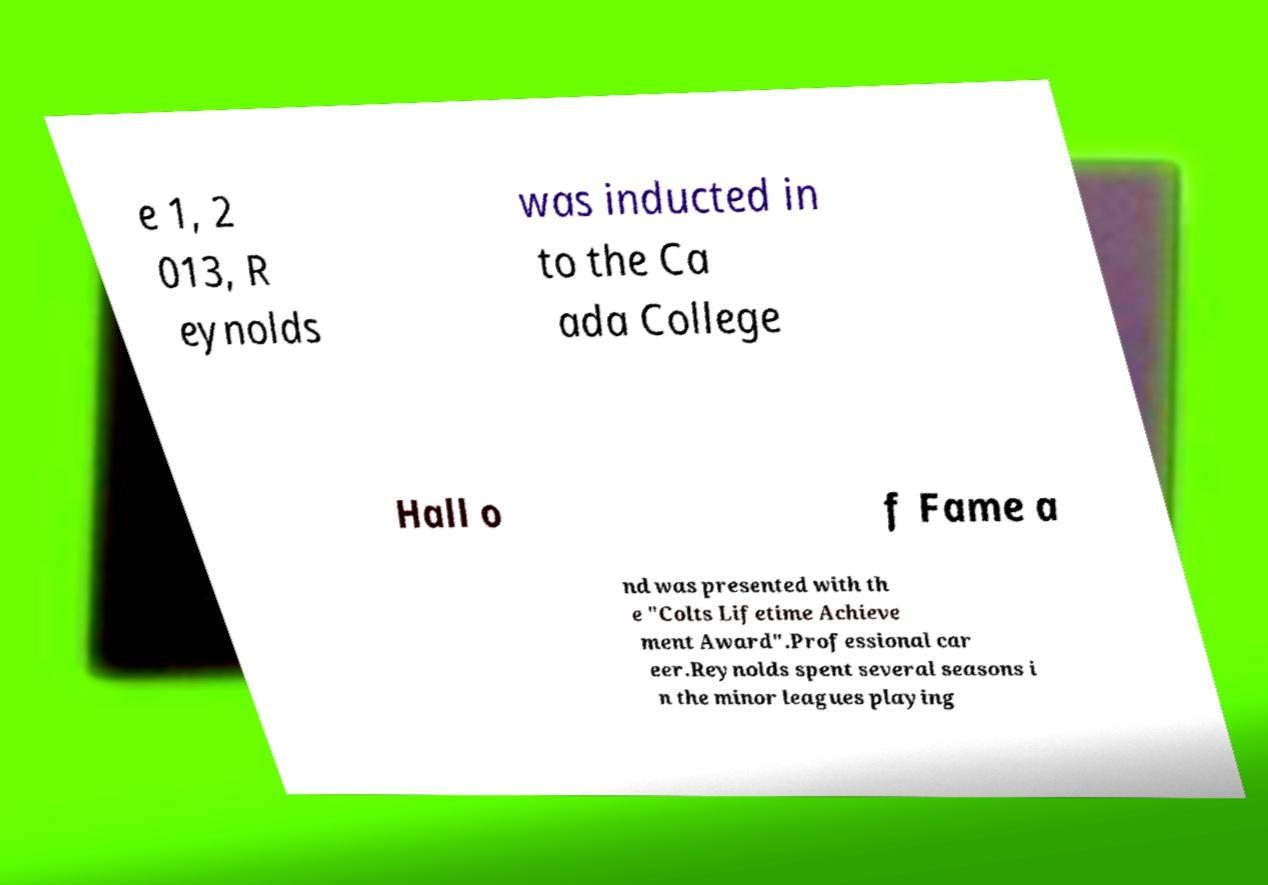I need the written content from this picture converted into text. Can you do that? e 1, 2 013, R eynolds was inducted in to the Ca ada College Hall o f Fame a nd was presented with th e "Colts Lifetime Achieve ment Award".Professional car eer.Reynolds spent several seasons i n the minor leagues playing 